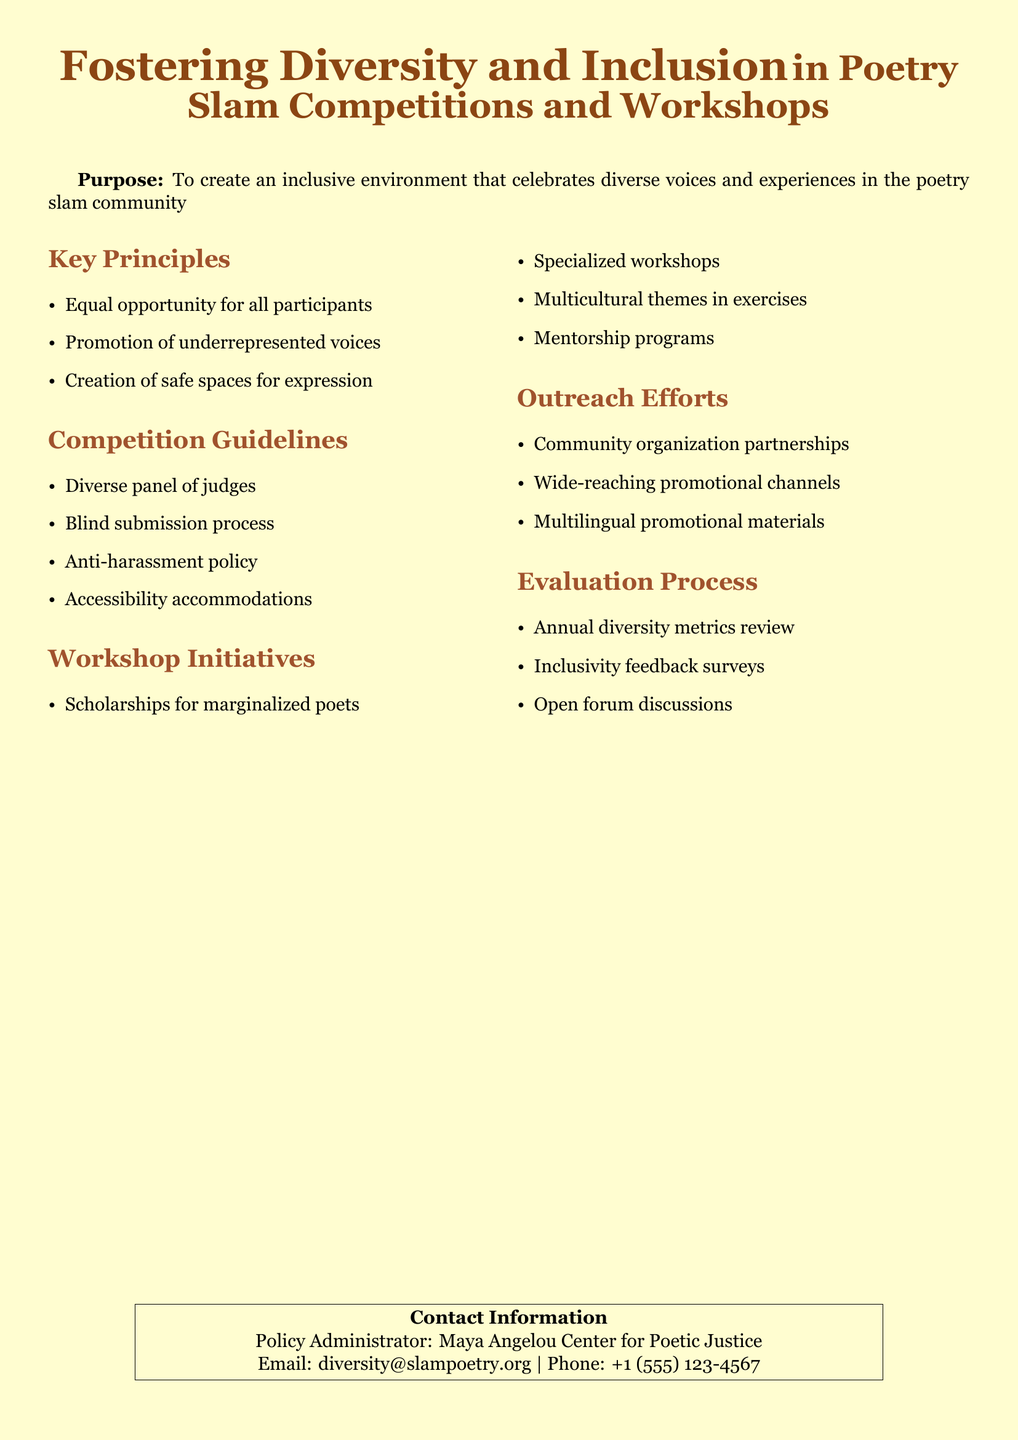What is the purpose of the document? The purpose section states that it aims to create an inclusive environment that celebrates diverse voices and experiences in the poetry slam community.
Answer: Create an inclusive environment What are the key principles outlined in the document? The key principles section lists three specific ideas: equal opportunity, promotion of underrepresented voices, and creation of safe spaces.
Answer: Equal opportunity for all participants How many workshops initiatives are mentioned? The document lists four specific workshop initiatives aimed at supporting diversity and inclusion in poetry.
Answer: Four What type of policy is this document categorized under? The title of the document indicates it is a policy related to fostering diversity and inclusion in specific activities.
Answer: Diversity and inclusion policy Who is the contact person for inquiries regarding this policy? The contact information section names a specific organization associated with the document for further queries.
Answer: Maya Angelou Center for Poetic Justice What is one guideline for competitions mentioned in the document? The competition guidelines section includes several crucial rules to ensure fairness and inclusiveness during events.
Answer: Blind submission process How does the document address accessibility? The competition guidelines include specific accommodations to ensure all participants can engage.
Answer: Accessibility accommodations What evaluation process is described in the document? The evaluation process outlines how the effectiveness and inclusivity of the policy will be measured over time.
Answer: Annual diversity metrics review Name one type of outreach effort mentioned. The outreach efforts section includes various methods that the organization will employ to ensure representation and participation from diverse groups.
Answer: Community organization partnerships 